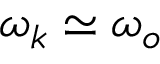Convert formula to latex. <formula><loc_0><loc_0><loc_500><loc_500>\omega _ { k } \simeq \omega _ { o }</formula> 